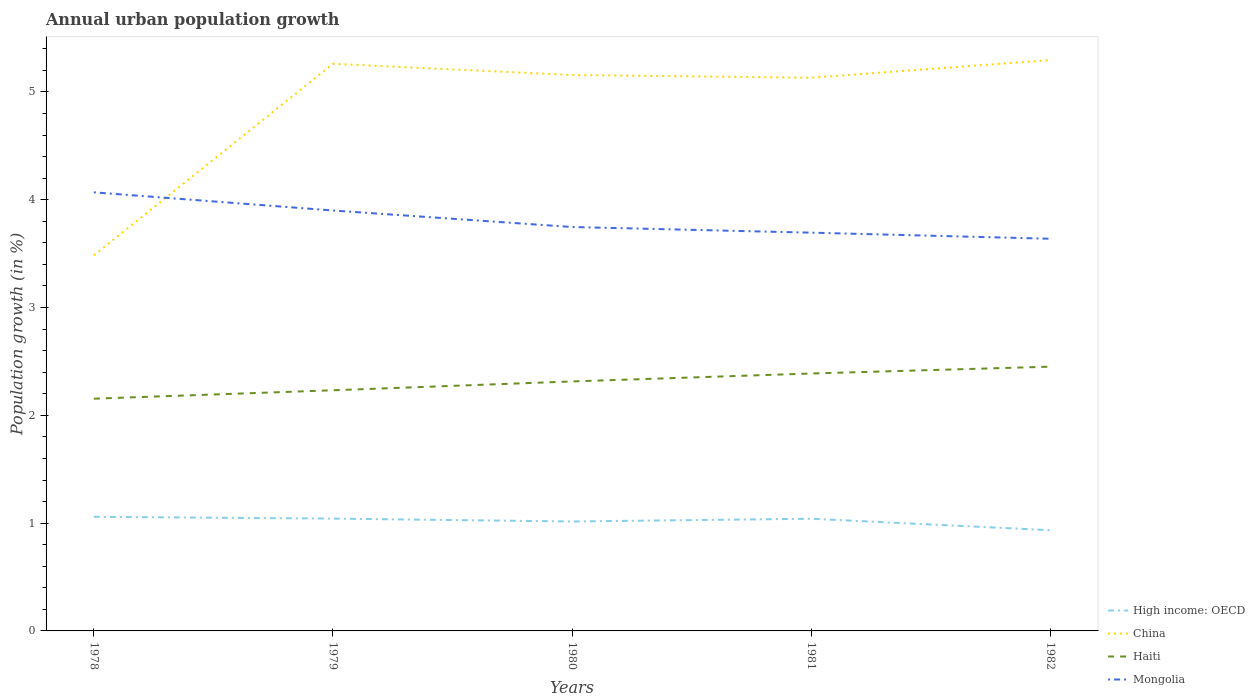How many different coloured lines are there?
Offer a very short reply. 4. Is the number of lines equal to the number of legend labels?
Give a very brief answer. Yes. Across all years, what is the maximum percentage of urban population growth in Mongolia?
Your answer should be compact. 3.64. In which year was the percentage of urban population growth in Mongolia maximum?
Give a very brief answer. 1982. What is the total percentage of urban population growth in China in the graph?
Offer a terse response. 0.03. What is the difference between the highest and the second highest percentage of urban population growth in Mongolia?
Provide a short and direct response. 0.43. What is the difference between the highest and the lowest percentage of urban population growth in High income: OECD?
Offer a very short reply. 3. Is the percentage of urban population growth in China strictly greater than the percentage of urban population growth in High income: OECD over the years?
Keep it short and to the point. No. How many lines are there?
Offer a terse response. 4. Are the values on the major ticks of Y-axis written in scientific E-notation?
Offer a very short reply. No. How are the legend labels stacked?
Provide a succinct answer. Vertical. What is the title of the graph?
Give a very brief answer. Annual urban population growth. What is the label or title of the Y-axis?
Ensure brevity in your answer.  Population growth (in %). What is the Population growth (in %) in High income: OECD in 1978?
Make the answer very short. 1.06. What is the Population growth (in %) in China in 1978?
Make the answer very short. 3.48. What is the Population growth (in %) in Haiti in 1978?
Keep it short and to the point. 2.15. What is the Population growth (in %) of Mongolia in 1978?
Provide a short and direct response. 4.07. What is the Population growth (in %) of High income: OECD in 1979?
Keep it short and to the point. 1.04. What is the Population growth (in %) of China in 1979?
Provide a succinct answer. 5.26. What is the Population growth (in %) of Haiti in 1979?
Offer a terse response. 2.23. What is the Population growth (in %) of Mongolia in 1979?
Ensure brevity in your answer.  3.9. What is the Population growth (in %) in High income: OECD in 1980?
Your response must be concise. 1.02. What is the Population growth (in %) in China in 1980?
Your answer should be compact. 5.16. What is the Population growth (in %) in Haiti in 1980?
Your answer should be compact. 2.31. What is the Population growth (in %) in Mongolia in 1980?
Offer a very short reply. 3.75. What is the Population growth (in %) in High income: OECD in 1981?
Give a very brief answer. 1.04. What is the Population growth (in %) of China in 1981?
Your answer should be very brief. 5.13. What is the Population growth (in %) of Haiti in 1981?
Give a very brief answer. 2.39. What is the Population growth (in %) in Mongolia in 1981?
Keep it short and to the point. 3.69. What is the Population growth (in %) of High income: OECD in 1982?
Your answer should be very brief. 0.93. What is the Population growth (in %) of China in 1982?
Make the answer very short. 5.3. What is the Population growth (in %) in Haiti in 1982?
Your response must be concise. 2.45. What is the Population growth (in %) of Mongolia in 1982?
Keep it short and to the point. 3.64. Across all years, what is the maximum Population growth (in %) in High income: OECD?
Provide a short and direct response. 1.06. Across all years, what is the maximum Population growth (in %) in China?
Offer a terse response. 5.3. Across all years, what is the maximum Population growth (in %) of Haiti?
Your answer should be very brief. 2.45. Across all years, what is the maximum Population growth (in %) of Mongolia?
Give a very brief answer. 4.07. Across all years, what is the minimum Population growth (in %) of High income: OECD?
Give a very brief answer. 0.93. Across all years, what is the minimum Population growth (in %) of China?
Ensure brevity in your answer.  3.48. Across all years, what is the minimum Population growth (in %) of Haiti?
Your answer should be very brief. 2.15. Across all years, what is the minimum Population growth (in %) of Mongolia?
Your response must be concise. 3.64. What is the total Population growth (in %) in High income: OECD in the graph?
Provide a succinct answer. 5.09. What is the total Population growth (in %) of China in the graph?
Provide a succinct answer. 24.33. What is the total Population growth (in %) of Haiti in the graph?
Your answer should be very brief. 11.54. What is the total Population growth (in %) of Mongolia in the graph?
Provide a succinct answer. 19.05. What is the difference between the Population growth (in %) of High income: OECD in 1978 and that in 1979?
Your response must be concise. 0.02. What is the difference between the Population growth (in %) in China in 1978 and that in 1979?
Your answer should be compact. -1.78. What is the difference between the Population growth (in %) in Haiti in 1978 and that in 1979?
Make the answer very short. -0.08. What is the difference between the Population growth (in %) of Mongolia in 1978 and that in 1979?
Your answer should be compact. 0.17. What is the difference between the Population growth (in %) of High income: OECD in 1978 and that in 1980?
Make the answer very short. 0.04. What is the difference between the Population growth (in %) of China in 1978 and that in 1980?
Ensure brevity in your answer.  -1.67. What is the difference between the Population growth (in %) of Haiti in 1978 and that in 1980?
Provide a short and direct response. -0.16. What is the difference between the Population growth (in %) of Mongolia in 1978 and that in 1980?
Ensure brevity in your answer.  0.32. What is the difference between the Population growth (in %) of High income: OECD in 1978 and that in 1981?
Offer a very short reply. 0.02. What is the difference between the Population growth (in %) of China in 1978 and that in 1981?
Offer a terse response. -1.65. What is the difference between the Population growth (in %) in Haiti in 1978 and that in 1981?
Give a very brief answer. -0.23. What is the difference between the Population growth (in %) of Mongolia in 1978 and that in 1981?
Give a very brief answer. 0.37. What is the difference between the Population growth (in %) in High income: OECD in 1978 and that in 1982?
Provide a succinct answer. 0.12. What is the difference between the Population growth (in %) of China in 1978 and that in 1982?
Make the answer very short. -1.81. What is the difference between the Population growth (in %) in Haiti in 1978 and that in 1982?
Your answer should be very brief. -0.3. What is the difference between the Population growth (in %) of Mongolia in 1978 and that in 1982?
Offer a terse response. 0.43. What is the difference between the Population growth (in %) of High income: OECD in 1979 and that in 1980?
Your response must be concise. 0.03. What is the difference between the Population growth (in %) in China in 1979 and that in 1980?
Provide a succinct answer. 0.1. What is the difference between the Population growth (in %) in Haiti in 1979 and that in 1980?
Your response must be concise. -0.08. What is the difference between the Population growth (in %) in Mongolia in 1979 and that in 1980?
Your response must be concise. 0.15. What is the difference between the Population growth (in %) of High income: OECD in 1979 and that in 1981?
Your answer should be compact. 0. What is the difference between the Population growth (in %) of China in 1979 and that in 1981?
Keep it short and to the point. 0.13. What is the difference between the Population growth (in %) in Haiti in 1979 and that in 1981?
Provide a short and direct response. -0.16. What is the difference between the Population growth (in %) in Mongolia in 1979 and that in 1981?
Keep it short and to the point. 0.21. What is the difference between the Population growth (in %) of High income: OECD in 1979 and that in 1982?
Your answer should be very brief. 0.11. What is the difference between the Population growth (in %) of China in 1979 and that in 1982?
Ensure brevity in your answer.  -0.03. What is the difference between the Population growth (in %) of Haiti in 1979 and that in 1982?
Provide a short and direct response. -0.22. What is the difference between the Population growth (in %) of Mongolia in 1979 and that in 1982?
Provide a short and direct response. 0.26. What is the difference between the Population growth (in %) of High income: OECD in 1980 and that in 1981?
Ensure brevity in your answer.  -0.03. What is the difference between the Population growth (in %) in China in 1980 and that in 1981?
Offer a very short reply. 0.03. What is the difference between the Population growth (in %) in Haiti in 1980 and that in 1981?
Your answer should be very brief. -0.07. What is the difference between the Population growth (in %) of Mongolia in 1980 and that in 1981?
Offer a terse response. 0.05. What is the difference between the Population growth (in %) of High income: OECD in 1980 and that in 1982?
Keep it short and to the point. 0.08. What is the difference between the Population growth (in %) in China in 1980 and that in 1982?
Your response must be concise. -0.14. What is the difference between the Population growth (in %) in Haiti in 1980 and that in 1982?
Make the answer very short. -0.14. What is the difference between the Population growth (in %) in Mongolia in 1980 and that in 1982?
Provide a succinct answer. 0.11. What is the difference between the Population growth (in %) of High income: OECD in 1981 and that in 1982?
Your answer should be compact. 0.11. What is the difference between the Population growth (in %) of China in 1981 and that in 1982?
Give a very brief answer. -0.16. What is the difference between the Population growth (in %) of Haiti in 1981 and that in 1982?
Offer a terse response. -0.06. What is the difference between the Population growth (in %) in Mongolia in 1981 and that in 1982?
Offer a terse response. 0.06. What is the difference between the Population growth (in %) of High income: OECD in 1978 and the Population growth (in %) of China in 1979?
Make the answer very short. -4.2. What is the difference between the Population growth (in %) of High income: OECD in 1978 and the Population growth (in %) of Haiti in 1979?
Offer a terse response. -1.17. What is the difference between the Population growth (in %) of High income: OECD in 1978 and the Population growth (in %) of Mongolia in 1979?
Your response must be concise. -2.84. What is the difference between the Population growth (in %) in China in 1978 and the Population growth (in %) in Haiti in 1979?
Give a very brief answer. 1.25. What is the difference between the Population growth (in %) in China in 1978 and the Population growth (in %) in Mongolia in 1979?
Offer a terse response. -0.42. What is the difference between the Population growth (in %) in Haiti in 1978 and the Population growth (in %) in Mongolia in 1979?
Ensure brevity in your answer.  -1.75. What is the difference between the Population growth (in %) in High income: OECD in 1978 and the Population growth (in %) in China in 1980?
Your response must be concise. -4.1. What is the difference between the Population growth (in %) of High income: OECD in 1978 and the Population growth (in %) of Haiti in 1980?
Keep it short and to the point. -1.26. What is the difference between the Population growth (in %) of High income: OECD in 1978 and the Population growth (in %) of Mongolia in 1980?
Make the answer very short. -2.69. What is the difference between the Population growth (in %) of China in 1978 and the Population growth (in %) of Haiti in 1980?
Ensure brevity in your answer.  1.17. What is the difference between the Population growth (in %) of China in 1978 and the Population growth (in %) of Mongolia in 1980?
Your answer should be compact. -0.26. What is the difference between the Population growth (in %) in Haiti in 1978 and the Population growth (in %) in Mongolia in 1980?
Keep it short and to the point. -1.59. What is the difference between the Population growth (in %) in High income: OECD in 1978 and the Population growth (in %) in China in 1981?
Keep it short and to the point. -4.07. What is the difference between the Population growth (in %) in High income: OECD in 1978 and the Population growth (in %) in Haiti in 1981?
Provide a short and direct response. -1.33. What is the difference between the Population growth (in %) of High income: OECD in 1978 and the Population growth (in %) of Mongolia in 1981?
Your answer should be very brief. -2.64. What is the difference between the Population growth (in %) in China in 1978 and the Population growth (in %) in Haiti in 1981?
Your response must be concise. 1.1. What is the difference between the Population growth (in %) of China in 1978 and the Population growth (in %) of Mongolia in 1981?
Provide a succinct answer. -0.21. What is the difference between the Population growth (in %) of Haiti in 1978 and the Population growth (in %) of Mongolia in 1981?
Offer a terse response. -1.54. What is the difference between the Population growth (in %) in High income: OECD in 1978 and the Population growth (in %) in China in 1982?
Offer a very short reply. -4.24. What is the difference between the Population growth (in %) in High income: OECD in 1978 and the Population growth (in %) in Haiti in 1982?
Give a very brief answer. -1.39. What is the difference between the Population growth (in %) of High income: OECD in 1978 and the Population growth (in %) of Mongolia in 1982?
Keep it short and to the point. -2.58. What is the difference between the Population growth (in %) in China in 1978 and the Population growth (in %) in Haiti in 1982?
Give a very brief answer. 1.03. What is the difference between the Population growth (in %) of China in 1978 and the Population growth (in %) of Mongolia in 1982?
Keep it short and to the point. -0.15. What is the difference between the Population growth (in %) of Haiti in 1978 and the Population growth (in %) of Mongolia in 1982?
Your response must be concise. -1.48. What is the difference between the Population growth (in %) of High income: OECD in 1979 and the Population growth (in %) of China in 1980?
Ensure brevity in your answer.  -4.12. What is the difference between the Population growth (in %) of High income: OECD in 1979 and the Population growth (in %) of Haiti in 1980?
Offer a terse response. -1.27. What is the difference between the Population growth (in %) of High income: OECD in 1979 and the Population growth (in %) of Mongolia in 1980?
Your response must be concise. -2.71. What is the difference between the Population growth (in %) of China in 1979 and the Population growth (in %) of Haiti in 1980?
Keep it short and to the point. 2.95. What is the difference between the Population growth (in %) in China in 1979 and the Population growth (in %) in Mongolia in 1980?
Give a very brief answer. 1.51. What is the difference between the Population growth (in %) of Haiti in 1979 and the Population growth (in %) of Mongolia in 1980?
Keep it short and to the point. -1.51. What is the difference between the Population growth (in %) in High income: OECD in 1979 and the Population growth (in %) in China in 1981?
Your response must be concise. -4.09. What is the difference between the Population growth (in %) of High income: OECD in 1979 and the Population growth (in %) of Haiti in 1981?
Provide a short and direct response. -1.35. What is the difference between the Population growth (in %) in High income: OECD in 1979 and the Population growth (in %) in Mongolia in 1981?
Offer a very short reply. -2.65. What is the difference between the Population growth (in %) in China in 1979 and the Population growth (in %) in Haiti in 1981?
Your response must be concise. 2.87. What is the difference between the Population growth (in %) in China in 1979 and the Population growth (in %) in Mongolia in 1981?
Offer a very short reply. 1.57. What is the difference between the Population growth (in %) of Haiti in 1979 and the Population growth (in %) of Mongolia in 1981?
Give a very brief answer. -1.46. What is the difference between the Population growth (in %) in High income: OECD in 1979 and the Population growth (in %) in China in 1982?
Keep it short and to the point. -4.25. What is the difference between the Population growth (in %) in High income: OECD in 1979 and the Population growth (in %) in Haiti in 1982?
Your answer should be very brief. -1.41. What is the difference between the Population growth (in %) in High income: OECD in 1979 and the Population growth (in %) in Mongolia in 1982?
Offer a terse response. -2.6. What is the difference between the Population growth (in %) in China in 1979 and the Population growth (in %) in Haiti in 1982?
Your answer should be compact. 2.81. What is the difference between the Population growth (in %) in China in 1979 and the Population growth (in %) in Mongolia in 1982?
Offer a very short reply. 1.62. What is the difference between the Population growth (in %) of Haiti in 1979 and the Population growth (in %) of Mongolia in 1982?
Provide a succinct answer. -1.41. What is the difference between the Population growth (in %) in High income: OECD in 1980 and the Population growth (in %) in China in 1981?
Give a very brief answer. -4.12. What is the difference between the Population growth (in %) of High income: OECD in 1980 and the Population growth (in %) of Haiti in 1981?
Your answer should be very brief. -1.37. What is the difference between the Population growth (in %) of High income: OECD in 1980 and the Population growth (in %) of Mongolia in 1981?
Provide a succinct answer. -2.68. What is the difference between the Population growth (in %) of China in 1980 and the Population growth (in %) of Haiti in 1981?
Ensure brevity in your answer.  2.77. What is the difference between the Population growth (in %) of China in 1980 and the Population growth (in %) of Mongolia in 1981?
Make the answer very short. 1.46. What is the difference between the Population growth (in %) of Haiti in 1980 and the Population growth (in %) of Mongolia in 1981?
Provide a succinct answer. -1.38. What is the difference between the Population growth (in %) in High income: OECD in 1980 and the Population growth (in %) in China in 1982?
Ensure brevity in your answer.  -4.28. What is the difference between the Population growth (in %) in High income: OECD in 1980 and the Population growth (in %) in Haiti in 1982?
Your response must be concise. -1.44. What is the difference between the Population growth (in %) in High income: OECD in 1980 and the Population growth (in %) in Mongolia in 1982?
Your answer should be compact. -2.62. What is the difference between the Population growth (in %) of China in 1980 and the Population growth (in %) of Haiti in 1982?
Keep it short and to the point. 2.71. What is the difference between the Population growth (in %) in China in 1980 and the Population growth (in %) in Mongolia in 1982?
Your response must be concise. 1.52. What is the difference between the Population growth (in %) of Haiti in 1980 and the Population growth (in %) of Mongolia in 1982?
Give a very brief answer. -1.32. What is the difference between the Population growth (in %) of High income: OECD in 1981 and the Population growth (in %) of China in 1982?
Give a very brief answer. -4.25. What is the difference between the Population growth (in %) in High income: OECD in 1981 and the Population growth (in %) in Haiti in 1982?
Provide a succinct answer. -1.41. What is the difference between the Population growth (in %) in High income: OECD in 1981 and the Population growth (in %) in Mongolia in 1982?
Provide a short and direct response. -2.6. What is the difference between the Population growth (in %) in China in 1981 and the Population growth (in %) in Haiti in 1982?
Provide a succinct answer. 2.68. What is the difference between the Population growth (in %) of China in 1981 and the Population growth (in %) of Mongolia in 1982?
Offer a very short reply. 1.49. What is the difference between the Population growth (in %) in Haiti in 1981 and the Population growth (in %) in Mongolia in 1982?
Provide a short and direct response. -1.25. What is the average Population growth (in %) of High income: OECD per year?
Make the answer very short. 1.02. What is the average Population growth (in %) of China per year?
Give a very brief answer. 4.87. What is the average Population growth (in %) in Haiti per year?
Offer a very short reply. 2.31. What is the average Population growth (in %) in Mongolia per year?
Your response must be concise. 3.81. In the year 1978, what is the difference between the Population growth (in %) in High income: OECD and Population growth (in %) in China?
Your answer should be compact. -2.43. In the year 1978, what is the difference between the Population growth (in %) in High income: OECD and Population growth (in %) in Haiti?
Provide a short and direct response. -1.1. In the year 1978, what is the difference between the Population growth (in %) of High income: OECD and Population growth (in %) of Mongolia?
Your response must be concise. -3.01. In the year 1978, what is the difference between the Population growth (in %) of China and Population growth (in %) of Haiti?
Your answer should be compact. 1.33. In the year 1978, what is the difference between the Population growth (in %) in China and Population growth (in %) in Mongolia?
Offer a terse response. -0.58. In the year 1978, what is the difference between the Population growth (in %) of Haiti and Population growth (in %) of Mongolia?
Your answer should be very brief. -1.91. In the year 1979, what is the difference between the Population growth (in %) of High income: OECD and Population growth (in %) of China?
Ensure brevity in your answer.  -4.22. In the year 1979, what is the difference between the Population growth (in %) in High income: OECD and Population growth (in %) in Haiti?
Your answer should be very brief. -1.19. In the year 1979, what is the difference between the Population growth (in %) in High income: OECD and Population growth (in %) in Mongolia?
Give a very brief answer. -2.86. In the year 1979, what is the difference between the Population growth (in %) of China and Population growth (in %) of Haiti?
Provide a short and direct response. 3.03. In the year 1979, what is the difference between the Population growth (in %) in China and Population growth (in %) in Mongolia?
Offer a very short reply. 1.36. In the year 1979, what is the difference between the Population growth (in %) of Haiti and Population growth (in %) of Mongolia?
Offer a terse response. -1.67. In the year 1980, what is the difference between the Population growth (in %) in High income: OECD and Population growth (in %) in China?
Your answer should be very brief. -4.14. In the year 1980, what is the difference between the Population growth (in %) in High income: OECD and Population growth (in %) in Haiti?
Provide a succinct answer. -1.3. In the year 1980, what is the difference between the Population growth (in %) of High income: OECD and Population growth (in %) of Mongolia?
Keep it short and to the point. -2.73. In the year 1980, what is the difference between the Population growth (in %) in China and Population growth (in %) in Haiti?
Offer a very short reply. 2.84. In the year 1980, what is the difference between the Population growth (in %) in China and Population growth (in %) in Mongolia?
Your response must be concise. 1.41. In the year 1980, what is the difference between the Population growth (in %) in Haiti and Population growth (in %) in Mongolia?
Offer a terse response. -1.43. In the year 1981, what is the difference between the Population growth (in %) of High income: OECD and Population growth (in %) of China?
Your answer should be compact. -4.09. In the year 1981, what is the difference between the Population growth (in %) of High income: OECD and Population growth (in %) of Haiti?
Your response must be concise. -1.35. In the year 1981, what is the difference between the Population growth (in %) of High income: OECD and Population growth (in %) of Mongolia?
Give a very brief answer. -2.65. In the year 1981, what is the difference between the Population growth (in %) in China and Population growth (in %) in Haiti?
Offer a very short reply. 2.74. In the year 1981, what is the difference between the Population growth (in %) in China and Population growth (in %) in Mongolia?
Keep it short and to the point. 1.44. In the year 1981, what is the difference between the Population growth (in %) of Haiti and Population growth (in %) of Mongolia?
Keep it short and to the point. -1.31. In the year 1982, what is the difference between the Population growth (in %) in High income: OECD and Population growth (in %) in China?
Your response must be concise. -4.36. In the year 1982, what is the difference between the Population growth (in %) in High income: OECD and Population growth (in %) in Haiti?
Provide a short and direct response. -1.52. In the year 1982, what is the difference between the Population growth (in %) of High income: OECD and Population growth (in %) of Mongolia?
Ensure brevity in your answer.  -2.7. In the year 1982, what is the difference between the Population growth (in %) of China and Population growth (in %) of Haiti?
Offer a very short reply. 2.84. In the year 1982, what is the difference between the Population growth (in %) of China and Population growth (in %) of Mongolia?
Your response must be concise. 1.66. In the year 1982, what is the difference between the Population growth (in %) of Haiti and Population growth (in %) of Mongolia?
Give a very brief answer. -1.19. What is the ratio of the Population growth (in %) of High income: OECD in 1978 to that in 1979?
Make the answer very short. 1.02. What is the ratio of the Population growth (in %) in China in 1978 to that in 1979?
Make the answer very short. 0.66. What is the ratio of the Population growth (in %) of Mongolia in 1978 to that in 1979?
Your answer should be compact. 1.04. What is the ratio of the Population growth (in %) in High income: OECD in 1978 to that in 1980?
Your answer should be compact. 1.04. What is the ratio of the Population growth (in %) in China in 1978 to that in 1980?
Provide a succinct answer. 0.68. What is the ratio of the Population growth (in %) of Haiti in 1978 to that in 1980?
Keep it short and to the point. 0.93. What is the ratio of the Population growth (in %) in Mongolia in 1978 to that in 1980?
Your answer should be very brief. 1.09. What is the ratio of the Population growth (in %) of High income: OECD in 1978 to that in 1981?
Offer a very short reply. 1.02. What is the ratio of the Population growth (in %) of China in 1978 to that in 1981?
Provide a short and direct response. 0.68. What is the ratio of the Population growth (in %) of Haiti in 1978 to that in 1981?
Your response must be concise. 0.9. What is the ratio of the Population growth (in %) in Mongolia in 1978 to that in 1981?
Provide a succinct answer. 1.1. What is the ratio of the Population growth (in %) in High income: OECD in 1978 to that in 1982?
Keep it short and to the point. 1.13. What is the ratio of the Population growth (in %) in China in 1978 to that in 1982?
Give a very brief answer. 0.66. What is the ratio of the Population growth (in %) of Haiti in 1978 to that in 1982?
Make the answer very short. 0.88. What is the ratio of the Population growth (in %) of Mongolia in 1978 to that in 1982?
Offer a very short reply. 1.12. What is the ratio of the Population growth (in %) in High income: OECD in 1979 to that in 1980?
Offer a terse response. 1.03. What is the ratio of the Population growth (in %) of China in 1979 to that in 1980?
Offer a terse response. 1.02. What is the ratio of the Population growth (in %) in Haiti in 1979 to that in 1980?
Make the answer very short. 0.96. What is the ratio of the Population growth (in %) of Mongolia in 1979 to that in 1980?
Offer a very short reply. 1.04. What is the ratio of the Population growth (in %) of China in 1979 to that in 1981?
Make the answer very short. 1.03. What is the ratio of the Population growth (in %) of Haiti in 1979 to that in 1981?
Offer a terse response. 0.93. What is the ratio of the Population growth (in %) of Mongolia in 1979 to that in 1981?
Ensure brevity in your answer.  1.06. What is the ratio of the Population growth (in %) in High income: OECD in 1979 to that in 1982?
Your answer should be compact. 1.12. What is the ratio of the Population growth (in %) of Haiti in 1979 to that in 1982?
Ensure brevity in your answer.  0.91. What is the ratio of the Population growth (in %) in Mongolia in 1979 to that in 1982?
Offer a terse response. 1.07. What is the ratio of the Population growth (in %) in High income: OECD in 1980 to that in 1981?
Provide a succinct answer. 0.98. What is the ratio of the Population growth (in %) in Haiti in 1980 to that in 1981?
Give a very brief answer. 0.97. What is the ratio of the Population growth (in %) in Mongolia in 1980 to that in 1981?
Give a very brief answer. 1.01. What is the ratio of the Population growth (in %) in High income: OECD in 1980 to that in 1982?
Provide a succinct answer. 1.09. What is the ratio of the Population growth (in %) of China in 1980 to that in 1982?
Provide a succinct answer. 0.97. What is the ratio of the Population growth (in %) of Haiti in 1980 to that in 1982?
Give a very brief answer. 0.94. What is the ratio of the Population growth (in %) in Mongolia in 1980 to that in 1982?
Make the answer very short. 1.03. What is the ratio of the Population growth (in %) of High income: OECD in 1981 to that in 1982?
Keep it short and to the point. 1.11. What is the ratio of the Population growth (in %) in China in 1981 to that in 1982?
Provide a short and direct response. 0.97. What is the ratio of the Population growth (in %) in Haiti in 1981 to that in 1982?
Provide a short and direct response. 0.97. What is the ratio of the Population growth (in %) in Mongolia in 1981 to that in 1982?
Make the answer very short. 1.02. What is the difference between the highest and the second highest Population growth (in %) of High income: OECD?
Your answer should be compact. 0.02. What is the difference between the highest and the second highest Population growth (in %) in China?
Provide a succinct answer. 0.03. What is the difference between the highest and the second highest Population growth (in %) in Haiti?
Keep it short and to the point. 0.06. What is the difference between the highest and the second highest Population growth (in %) of Mongolia?
Provide a succinct answer. 0.17. What is the difference between the highest and the lowest Population growth (in %) in High income: OECD?
Ensure brevity in your answer.  0.12. What is the difference between the highest and the lowest Population growth (in %) of China?
Provide a short and direct response. 1.81. What is the difference between the highest and the lowest Population growth (in %) of Haiti?
Your answer should be compact. 0.3. What is the difference between the highest and the lowest Population growth (in %) of Mongolia?
Ensure brevity in your answer.  0.43. 